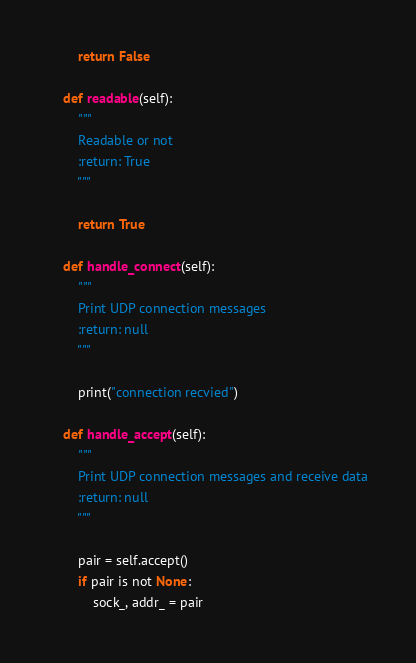<code> <loc_0><loc_0><loc_500><loc_500><_Python_>
        return False

    def readable(self):
        """
        Readable or not
        :return: True
        """

        return True

    def handle_connect(self):
        """
        Print UDP connection messages
        :return: null
        """

        print("connection recvied")

    def handle_accept(self):
        """
        Print UDP connection messages and receive data
        :return: null
        """

        pair = self.accept()
        if pair is not None:
            sock_, addr_ = pair</code> 